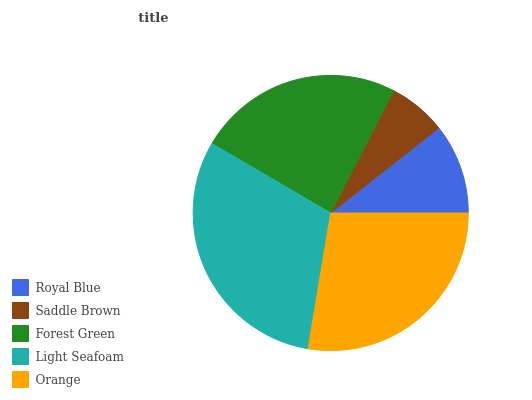Is Saddle Brown the minimum?
Answer yes or no. Yes. Is Light Seafoam the maximum?
Answer yes or no. Yes. Is Forest Green the minimum?
Answer yes or no. No. Is Forest Green the maximum?
Answer yes or no. No. Is Forest Green greater than Saddle Brown?
Answer yes or no. Yes. Is Saddle Brown less than Forest Green?
Answer yes or no. Yes. Is Saddle Brown greater than Forest Green?
Answer yes or no. No. Is Forest Green less than Saddle Brown?
Answer yes or no. No. Is Forest Green the high median?
Answer yes or no. Yes. Is Forest Green the low median?
Answer yes or no. Yes. Is Saddle Brown the high median?
Answer yes or no. No. Is Light Seafoam the low median?
Answer yes or no. No. 